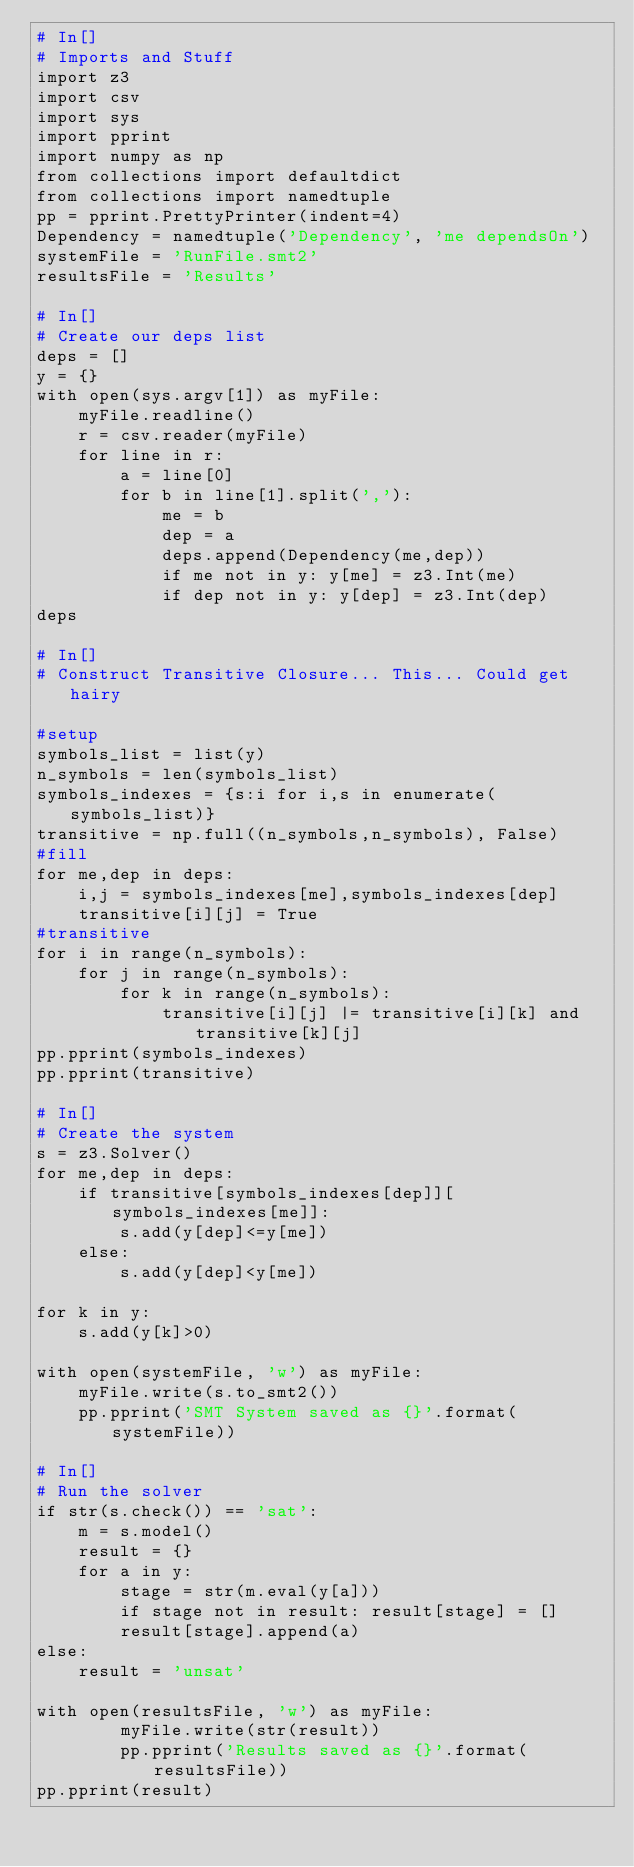<code> <loc_0><loc_0><loc_500><loc_500><_Python_># In[]
# Imports and Stuff
import z3
import csv
import sys
import pprint
import numpy as np
from collections import defaultdict
from collections import namedtuple
pp = pprint.PrettyPrinter(indent=4)
Dependency = namedtuple('Dependency', 'me dependsOn')
systemFile = 'RunFile.smt2'
resultsFile = 'Results'

# In[]
# Create our deps list
deps = []
y = {}
with open(sys.argv[1]) as myFile:
    myFile.readline()
    r = csv.reader(myFile)
    for line in r:
        a = line[0]
        for b in line[1].split(','):
            me = b
            dep = a
            deps.append(Dependency(me,dep))
            if me not in y: y[me] = z3.Int(me)
            if dep not in y: y[dep] = z3.Int(dep)
deps

# In[]
# Construct Transitive Closure... This... Could get hairy

#setup
symbols_list = list(y)
n_symbols = len(symbols_list)
symbols_indexes = {s:i for i,s in enumerate(symbols_list)}
transitive = np.full((n_symbols,n_symbols), False)
#fill
for me,dep in deps:
    i,j = symbols_indexes[me],symbols_indexes[dep]
    transitive[i][j] = True
#transitive
for i in range(n_symbols):
    for j in range(n_symbols):
        for k in range(n_symbols):
            transitive[i][j] |= transitive[i][k] and transitive[k][j]
pp.pprint(symbols_indexes)
pp.pprint(transitive)

# In[]
# Create the system
s = z3.Solver()
for me,dep in deps:    
    if transitive[symbols_indexes[dep]][symbols_indexes[me]]:
        s.add(y[dep]<=y[me])
    else:
        s.add(y[dep]<y[me])

for k in y:
    s.add(y[k]>0)

with open(systemFile, 'w') as myFile:
    myFile.write(s.to_smt2())
    pp.pprint('SMT System saved as {}'.format(systemFile))

# In[]
# Run the solver
if str(s.check()) == 'sat':
    m = s.model()
    result = {}
    for a in y:
        stage = str(m.eval(y[a]))
        if stage not in result: result[stage] = []
        result[stage].append(a)
else:
    result = 'unsat'

with open(resultsFile, 'w') as myFile:
        myFile.write(str(result))
        pp.pprint('Results saved as {}'.format(resultsFile))
pp.pprint(result)

</code> 